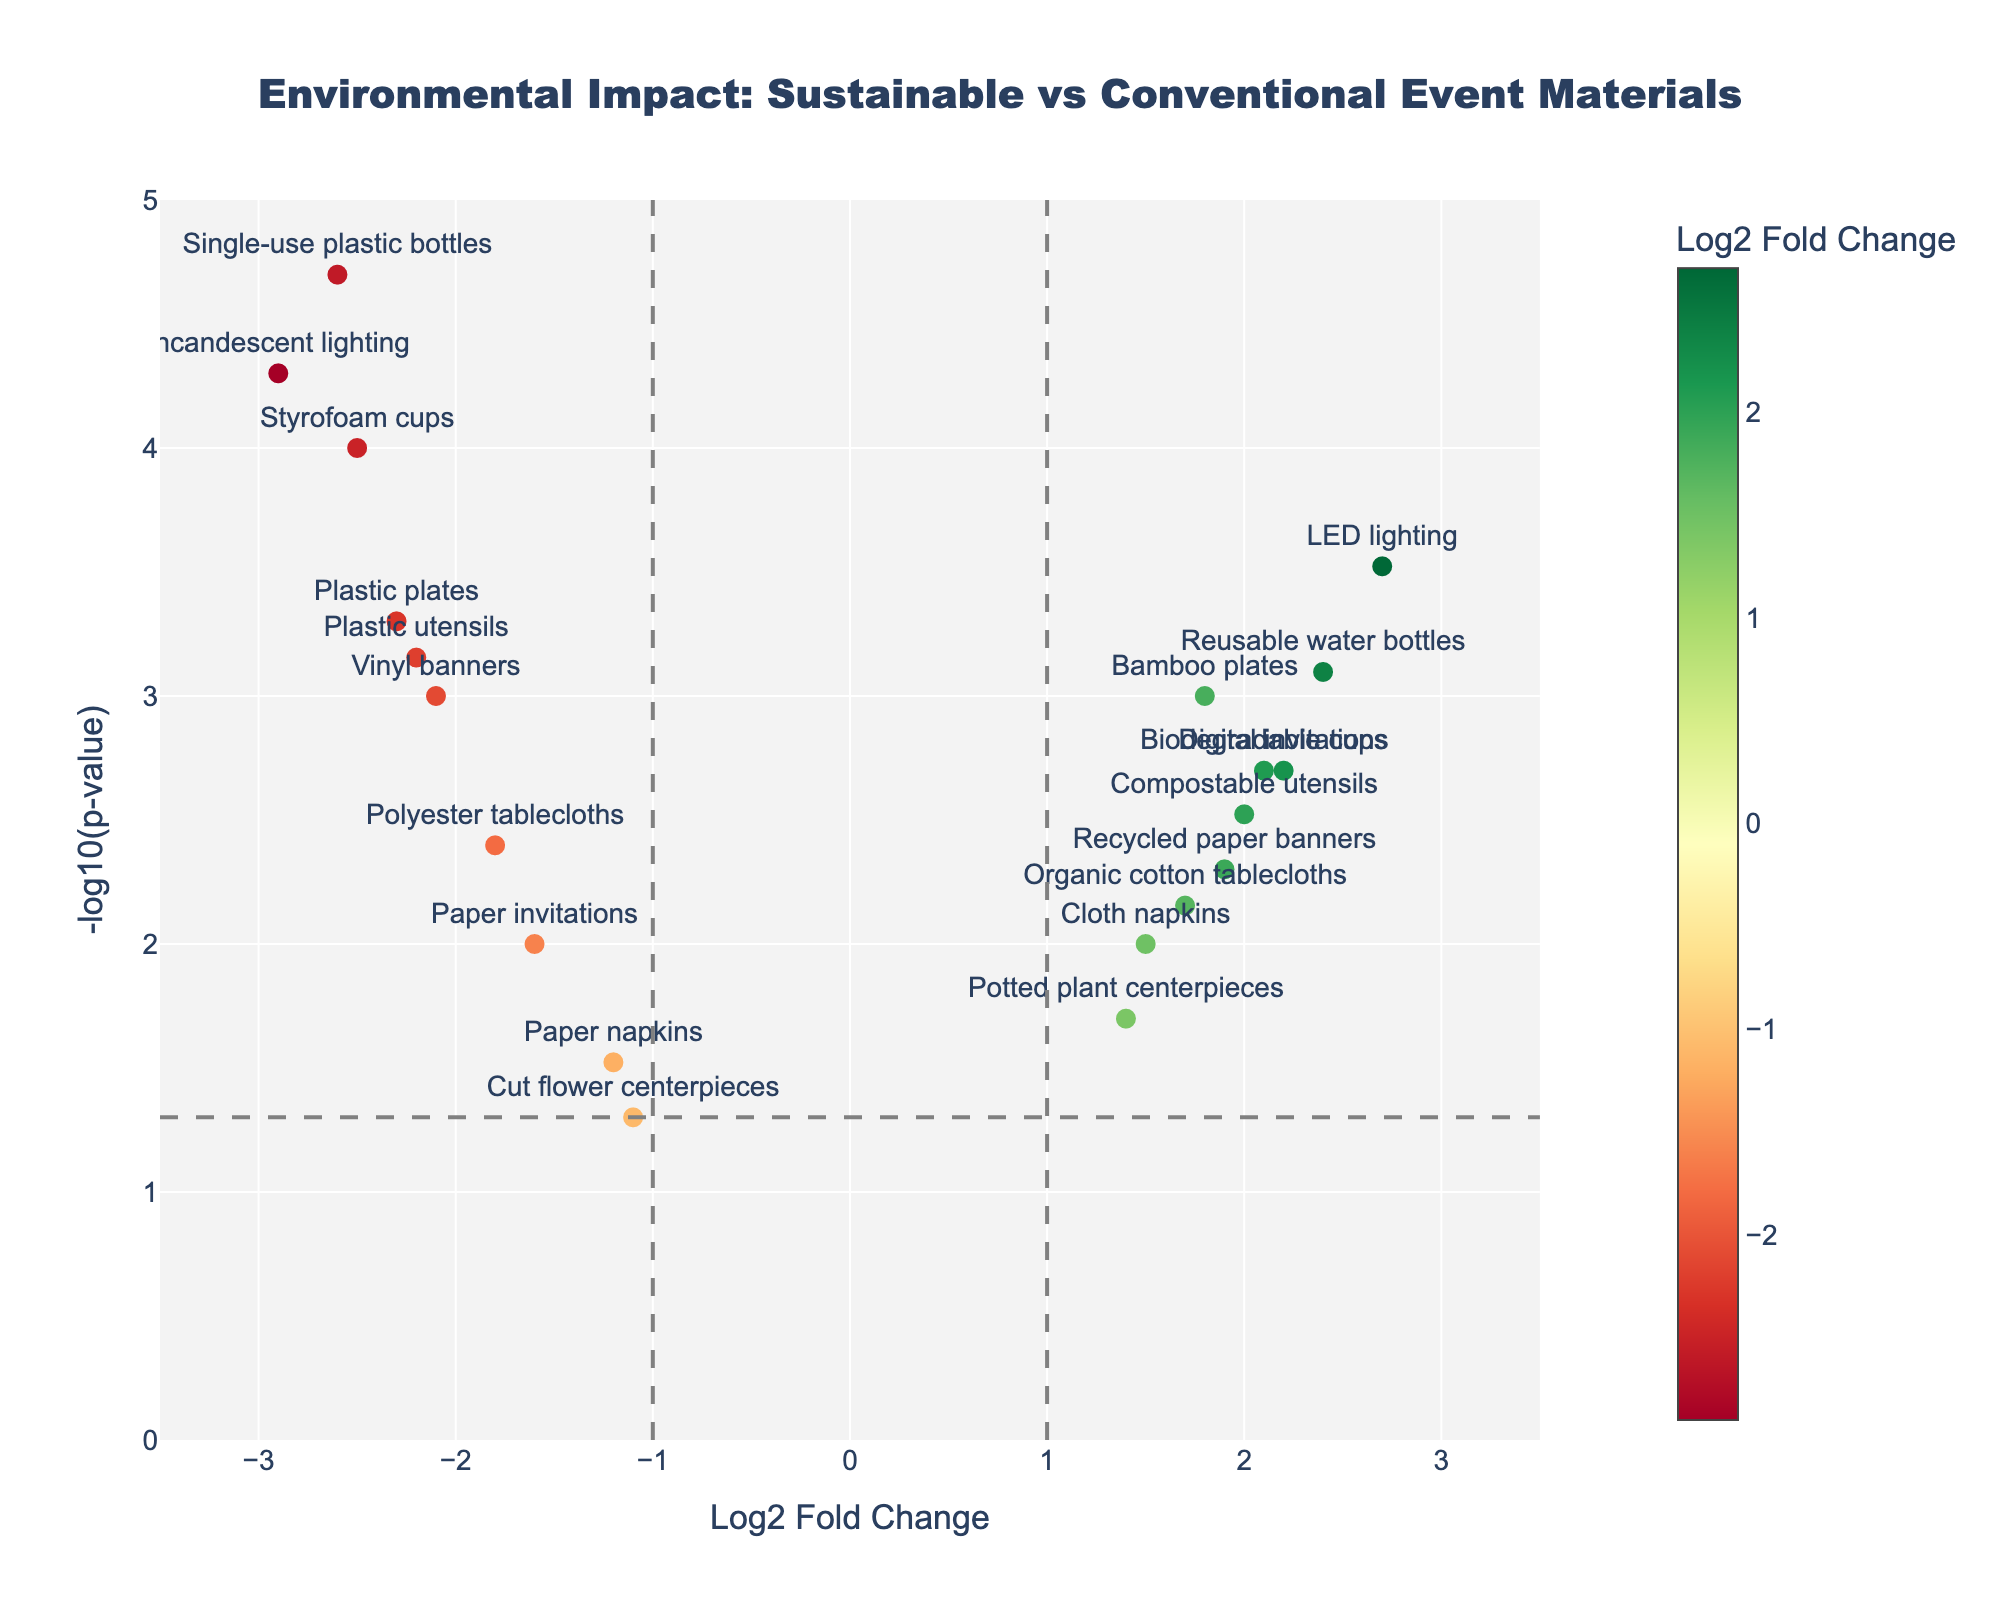What is the title of the figure? The title is usually placed at the top of the figure and provides a summary of what the figure represents. In this case, the title describes the comparative study of environmental impact between sustainable and conventional event materials.
Answer: Environmental Impact: Sustainable vs Conventional Event Materials How many data points are on the right side of the x-axis? The right side of the x-axis represents positive log2 fold changes. Count the number of data points to the right of the centerline (x=0).
Answer: 10 Which material has the largest positive log2 fold change? Locate the data point with the highest value on the x-axis among those with positive values, as this indicates the largest positive log2 fold change.
Answer: LED lighting Which material has the smallest p-value? The p-value is displayed on the y-axis as -log10(p-value). A higher y-axis value indicates a smaller p-value. Identify the data point with the highest position on the y-axis.
Answer: Single-use plastic bottles What is the significance threshold indicated by the horizontal line? The horizontal line represents the threshold for the significance level, usually set at p = 0.05. The -log10 transformation of 0.05 gives a value around 1.3, indicated by the position of the line on the y-axis.
Answer: 0.05 Which material shows the most significant negative environmental impact? The most significant negative environmental impact corresponds to the leftmost point on the x-axis since this represents the largest negative log2 fold change. Verify by also considering the height on the y-axis.
Answer: Incandescent lighting Compare the environmental impact between Bamboo plates and Plastic plates. Which has a more positive log2 fold change? Bamboo plates and Plastic plates' log2 fold changes can be compared by identifying their positions relative to each other on the x-axis. The material further to the right has a more positive log2 fold change.
Answer: Bamboo plates Are there any materials with a p-value higher than the significance threshold? Materials with a p-value higher than the threshold of 0.05 will have points below the horizontal significance line on the y-axis. Identify those points.
Answer: Cut flower centerpieces Which material has a more significant impact, Cloth napkins or Paper invitations, based on the p-value? Compare the heights on the y-axis of Cloth napkins and Paper invitations. The higher the point, the more significant the impact (lower p-value).
Answer: Paper invitations What are the most environmentally friendly materials based on the figure? Environmentally friendly materials will have positive log2 fold changes (right side of the x-axis) and high significance (above the horizontal line on the y-axis). List the materials that meet these criteria.
Answer: Bamboo plates, Biodegradable cups, LED lighting, Recycled paper banners, Reusable water bottles, Organic cotton tablecloths, Digital invitations, Compostable utensils 